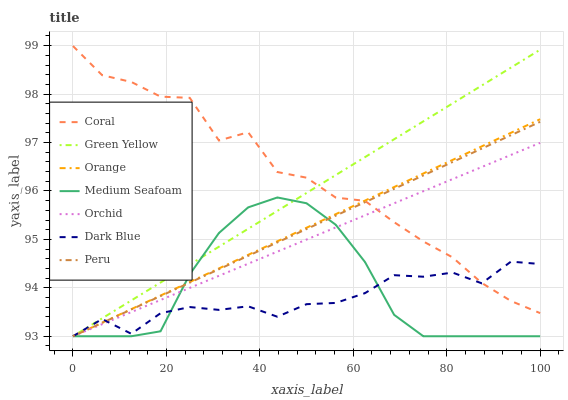Does Dark Blue have the minimum area under the curve?
Answer yes or no. Yes. Does Coral have the maximum area under the curve?
Answer yes or no. Yes. Does Peru have the minimum area under the curve?
Answer yes or no. No. Does Peru have the maximum area under the curve?
Answer yes or no. No. Is Orange the smoothest?
Answer yes or no. Yes. Is Coral the roughest?
Answer yes or no. Yes. Is Dark Blue the smoothest?
Answer yes or no. No. Is Dark Blue the roughest?
Answer yes or no. No. Does Coral have the highest value?
Answer yes or no. Yes. Does Peru have the highest value?
Answer yes or no. No. Is Medium Seafoam less than Coral?
Answer yes or no. Yes. Is Coral greater than Medium Seafoam?
Answer yes or no. Yes. Does Green Yellow intersect Dark Blue?
Answer yes or no. Yes. Is Green Yellow less than Dark Blue?
Answer yes or no. No. Is Green Yellow greater than Dark Blue?
Answer yes or no. No. Does Medium Seafoam intersect Coral?
Answer yes or no. No. 